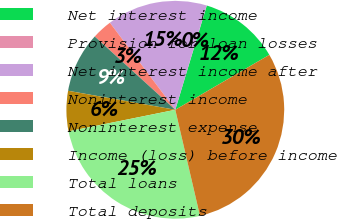Convert chart. <chart><loc_0><loc_0><loc_500><loc_500><pie_chart><fcel>Net interest income<fcel>Provision for loan losses<fcel>Net interest income after<fcel>Noninterest income<fcel>Noninterest expense<fcel>Income (loss) before income<fcel>Total loans<fcel>Total deposits<nl><fcel>11.92%<fcel>0.02%<fcel>14.9%<fcel>3.0%<fcel>8.95%<fcel>5.97%<fcel>25.46%<fcel>29.77%<nl></chart> 